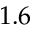<formula> <loc_0><loc_0><loc_500><loc_500>1 . 6</formula> 